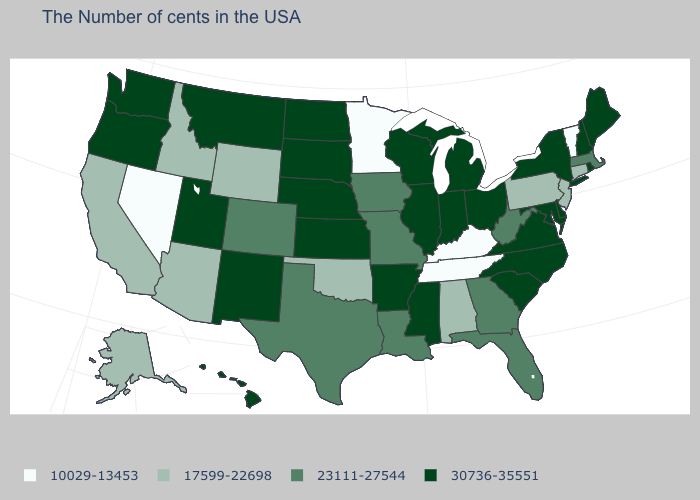Which states have the lowest value in the USA?
Answer briefly. Vermont, Kentucky, Tennessee, Minnesota, Nevada. Among the states that border Arizona , which have the highest value?
Answer briefly. New Mexico, Utah. Which states have the lowest value in the USA?
Quick response, please. Vermont, Kentucky, Tennessee, Minnesota, Nevada. Name the states that have a value in the range 10029-13453?
Give a very brief answer. Vermont, Kentucky, Tennessee, Minnesota, Nevada. What is the value of Arkansas?
Write a very short answer. 30736-35551. What is the value of New Hampshire?
Short answer required. 30736-35551. What is the value of Arkansas?
Concise answer only. 30736-35551. Does Arizona have a lower value than West Virginia?
Give a very brief answer. Yes. Among the states that border Washington , which have the highest value?
Concise answer only. Oregon. What is the highest value in the Northeast ?
Be succinct. 30736-35551. Which states have the highest value in the USA?
Short answer required. Maine, Rhode Island, New Hampshire, New York, Delaware, Maryland, Virginia, North Carolina, South Carolina, Ohio, Michigan, Indiana, Wisconsin, Illinois, Mississippi, Arkansas, Kansas, Nebraska, South Dakota, North Dakota, New Mexico, Utah, Montana, Washington, Oregon, Hawaii. What is the value of Maine?
Write a very short answer. 30736-35551. Which states have the highest value in the USA?
Quick response, please. Maine, Rhode Island, New Hampshire, New York, Delaware, Maryland, Virginia, North Carolina, South Carolina, Ohio, Michigan, Indiana, Wisconsin, Illinois, Mississippi, Arkansas, Kansas, Nebraska, South Dakota, North Dakota, New Mexico, Utah, Montana, Washington, Oregon, Hawaii. Does Alabama have the lowest value in the South?
Short answer required. No. Name the states that have a value in the range 10029-13453?
Answer briefly. Vermont, Kentucky, Tennessee, Minnesota, Nevada. 